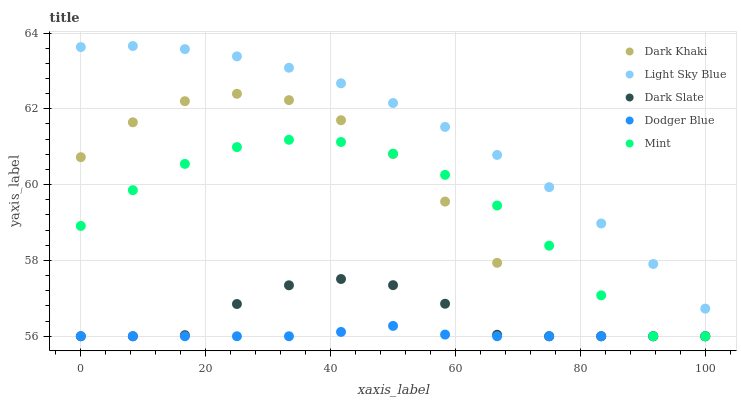Does Dodger Blue have the minimum area under the curve?
Answer yes or no. Yes. Does Light Sky Blue have the maximum area under the curve?
Answer yes or no. Yes. Does Dark Slate have the minimum area under the curve?
Answer yes or no. No. Does Dark Slate have the maximum area under the curve?
Answer yes or no. No. Is Dodger Blue the smoothest?
Answer yes or no. Yes. Is Dark Khaki the roughest?
Answer yes or no. Yes. Is Dark Slate the smoothest?
Answer yes or no. No. Is Dark Slate the roughest?
Answer yes or no. No. Does Dark Khaki have the lowest value?
Answer yes or no. Yes. Does Light Sky Blue have the lowest value?
Answer yes or no. No. Does Light Sky Blue have the highest value?
Answer yes or no. Yes. Does Dark Slate have the highest value?
Answer yes or no. No. Is Dark Slate less than Light Sky Blue?
Answer yes or no. Yes. Is Light Sky Blue greater than Dodger Blue?
Answer yes or no. Yes. Does Dodger Blue intersect Dark Khaki?
Answer yes or no. Yes. Is Dodger Blue less than Dark Khaki?
Answer yes or no. No. Is Dodger Blue greater than Dark Khaki?
Answer yes or no. No. Does Dark Slate intersect Light Sky Blue?
Answer yes or no. No. 